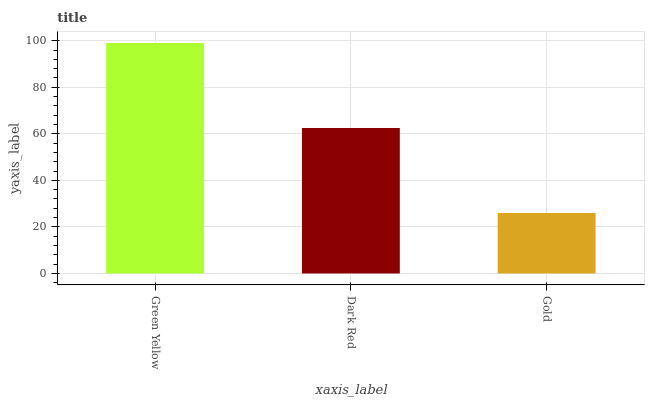Is Gold the minimum?
Answer yes or no. Yes. Is Green Yellow the maximum?
Answer yes or no. Yes. Is Dark Red the minimum?
Answer yes or no. No. Is Dark Red the maximum?
Answer yes or no. No. Is Green Yellow greater than Dark Red?
Answer yes or no. Yes. Is Dark Red less than Green Yellow?
Answer yes or no. Yes. Is Dark Red greater than Green Yellow?
Answer yes or no. No. Is Green Yellow less than Dark Red?
Answer yes or no. No. Is Dark Red the high median?
Answer yes or no. Yes. Is Dark Red the low median?
Answer yes or no. Yes. Is Green Yellow the high median?
Answer yes or no. No. Is Green Yellow the low median?
Answer yes or no. No. 